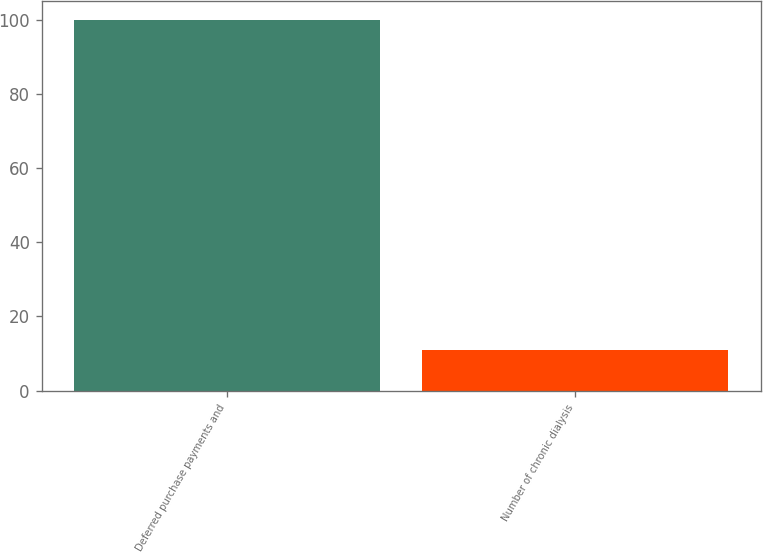<chart> <loc_0><loc_0><loc_500><loc_500><bar_chart><fcel>Deferred purchase payments and<fcel>Number of chronic dialysis<nl><fcel>100<fcel>11<nl></chart> 